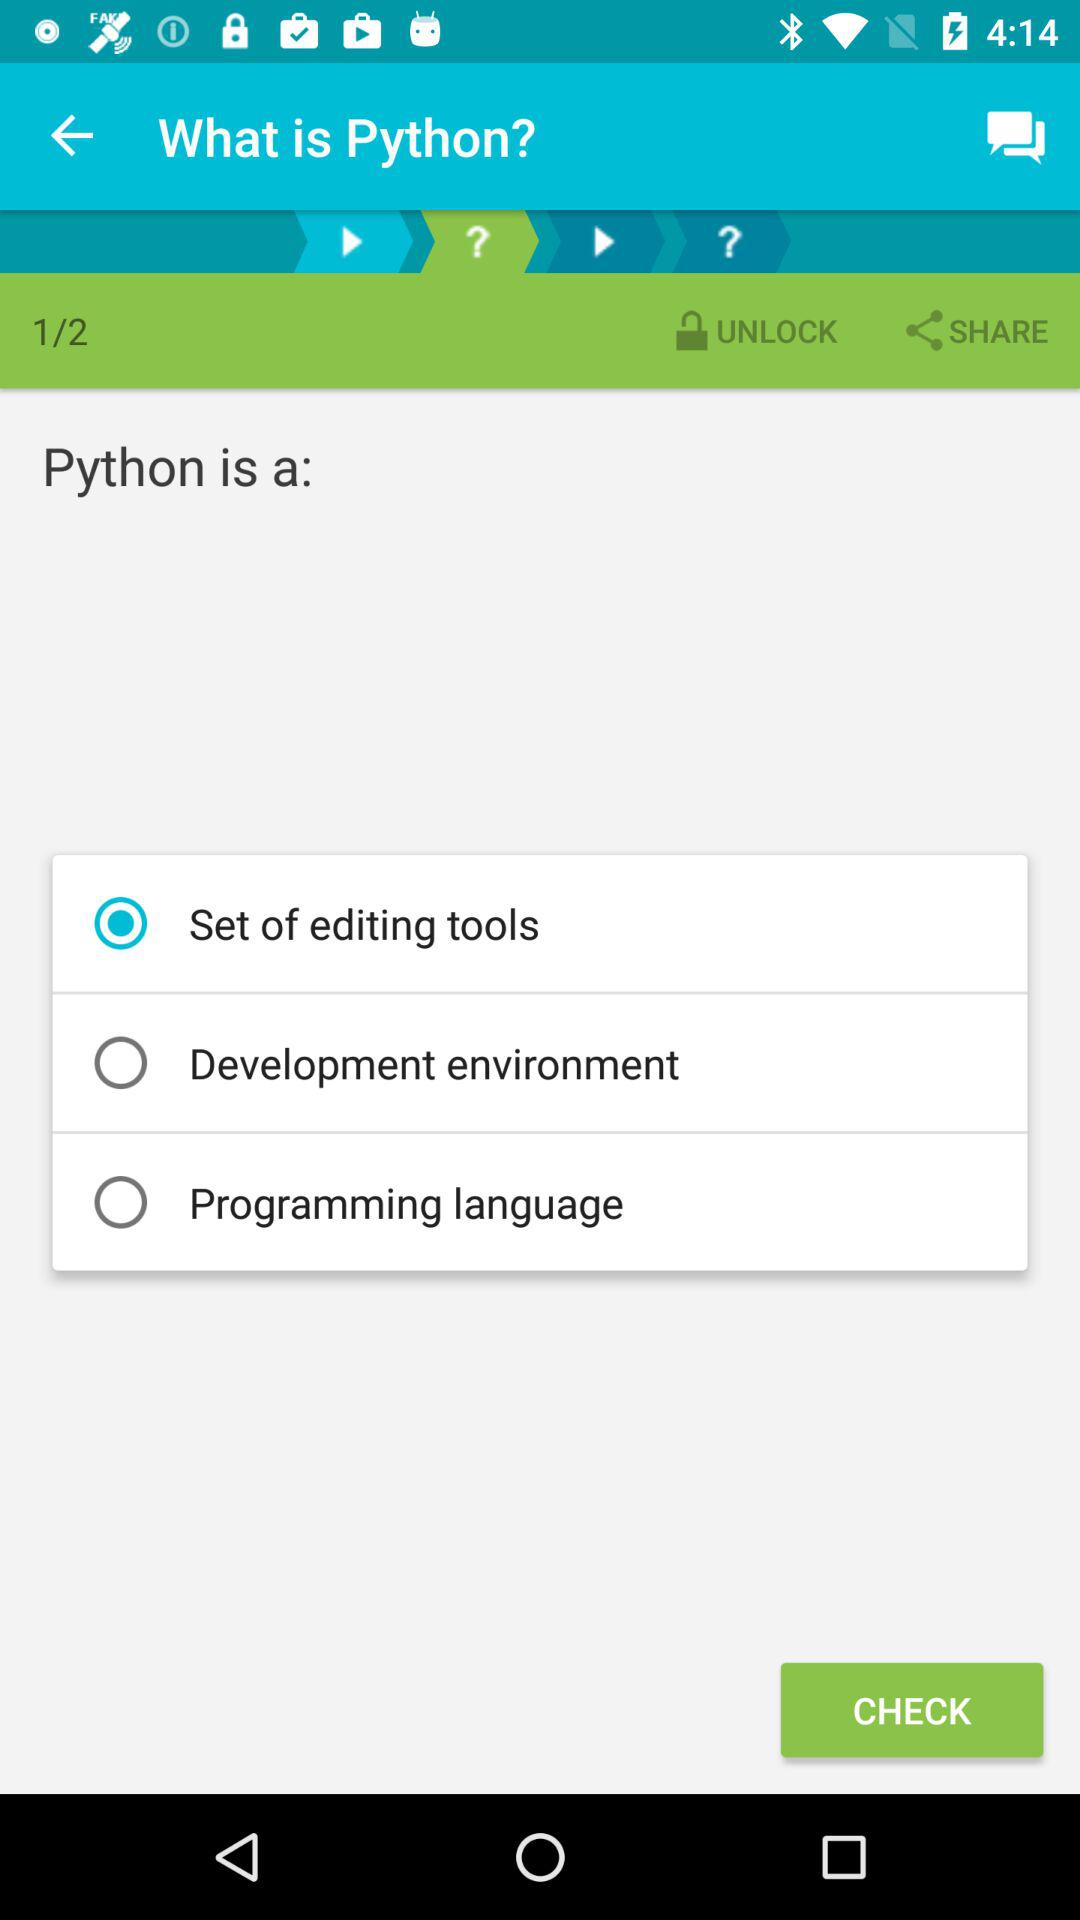Which option is selected? The selected option is "Set of editing tools". 